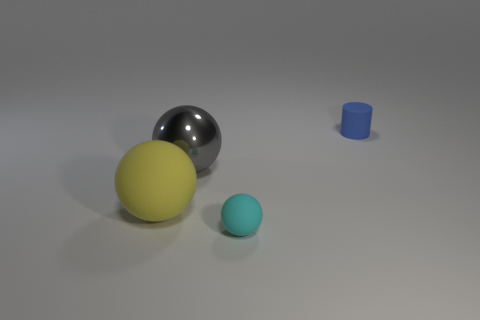Add 3 big yellow cubes. How many objects exist? 7 Subtract all cylinders. How many objects are left? 3 Subtract all big gray metallic balls. Subtract all large yellow rubber objects. How many objects are left? 2 Add 2 big yellow matte spheres. How many big yellow matte spheres are left? 3 Add 1 big metal objects. How many big metal objects exist? 2 Subtract 0 purple balls. How many objects are left? 4 